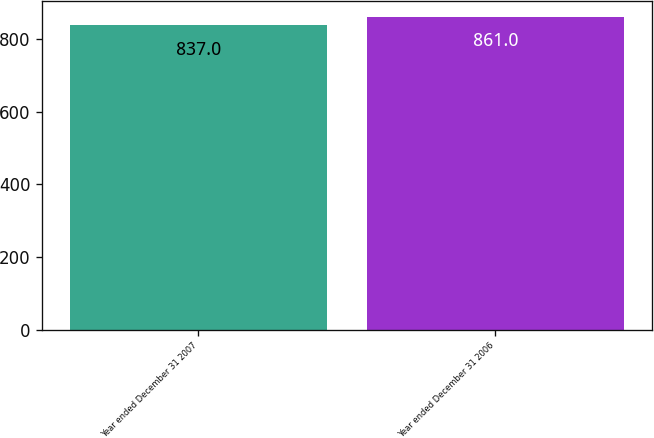Convert chart. <chart><loc_0><loc_0><loc_500><loc_500><bar_chart><fcel>Year ended December 31 2007<fcel>Year ended December 31 2006<nl><fcel>837<fcel>861<nl></chart> 